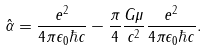Convert formula to latex. <formula><loc_0><loc_0><loc_500><loc_500>\hat { \alpha } = \frac { e ^ { 2 } } { 4 \pi \epsilon _ { 0 } \hbar { c } } - \frac { \pi } { 4 } \frac { G \mu } { c ^ { 2 } } \frac { e ^ { 2 } } { 4 \pi \epsilon _ { 0 } \hbar { c } } .</formula> 